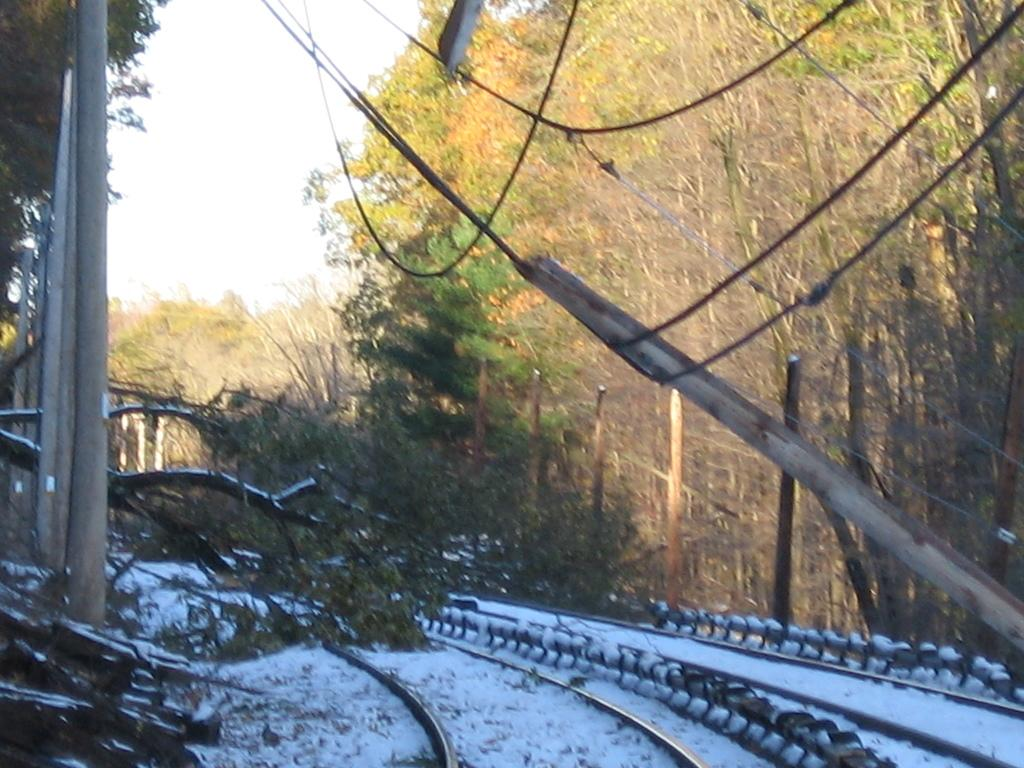What type of weather is depicted in the image? There is snow in the image, indicating a winter scene. What structures can be seen in the image? There are poles in the image. What type of natural vegetation is present in the image? There are trees in the image. What is visible in the background of the image? The sky is visible in the image. What type of animal can be seen interacting with the calendar in the image? There is no calendar or animal present in the image. What type of party is being held in the image? There is no party depicted in the image. 